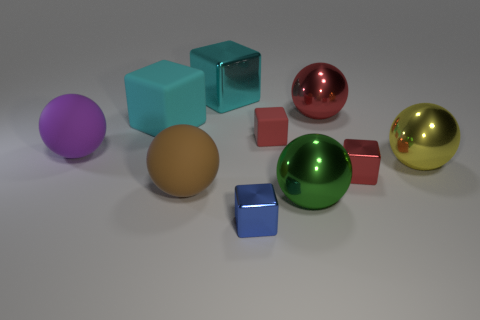There is another block that is the same color as the big metallic block; what is its size?
Keep it short and to the point. Large. What is the color of the other rubber cube that is the same size as the blue block?
Offer a very short reply. Red. Do the tiny red block that is behind the big yellow object and the yellow sphere have the same material?
Provide a short and direct response. No. Are there any red metal cubes behind the small metal object that is to the right of the red cube that is behind the big yellow metallic thing?
Your response must be concise. No. There is a red thing in front of the large yellow metallic object; does it have the same shape as the large brown rubber object?
Keep it short and to the point. No. The matte object that is in front of the red metallic thing that is in front of the large cyan rubber object is what shape?
Provide a short and direct response. Sphere. There is a object to the right of the red cube that is in front of the object that is right of the red metal cube; how big is it?
Provide a short and direct response. Large. There is another rubber object that is the same shape as the brown thing; what color is it?
Your response must be concise. Purple. Do the brown rubber object and the green metallic thing have the same size?
Your answer should be compact. Yes. There is a big block in front of the big red ball; what is it made of?
Give a very brief answer. Rubber. 